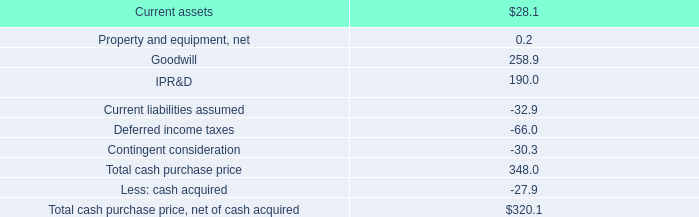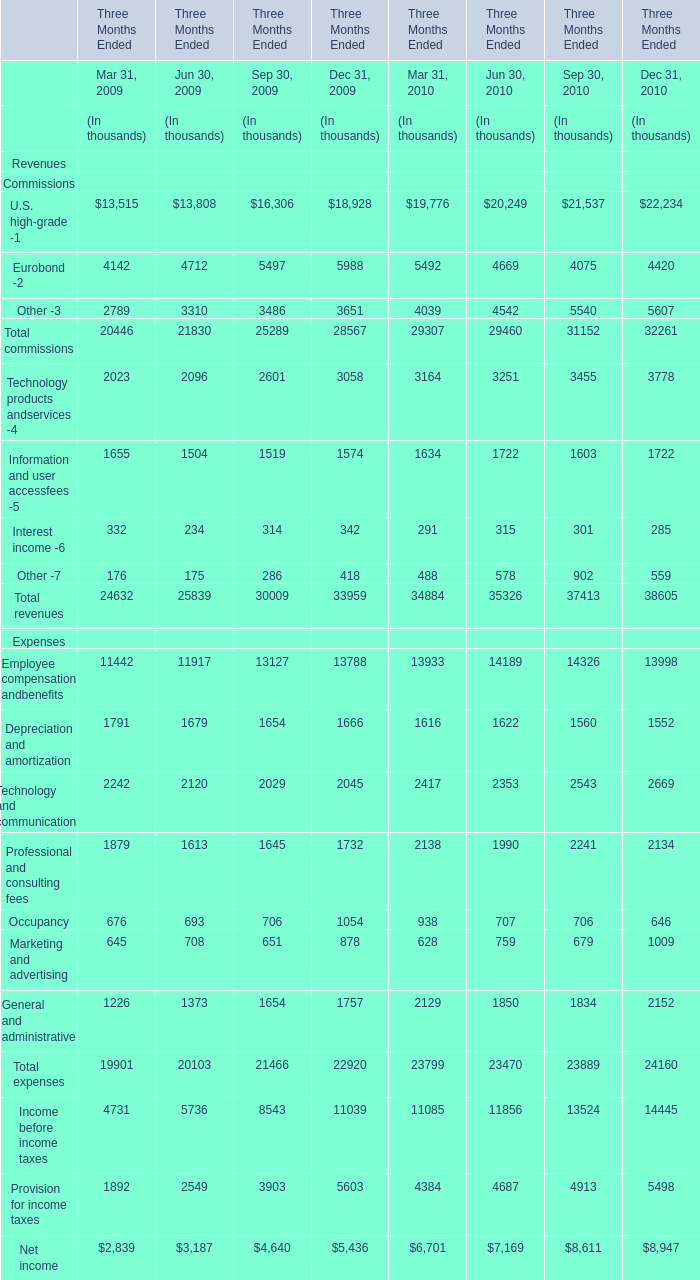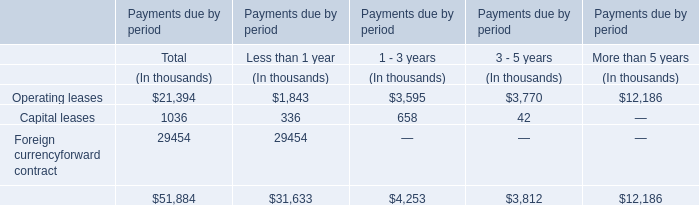What is the sum of Eurobond -2 in the range of 5000 and 6000 in 2009? (in thousand) 
Computations: (5497 + 5988)
Answer: 11485.0. 